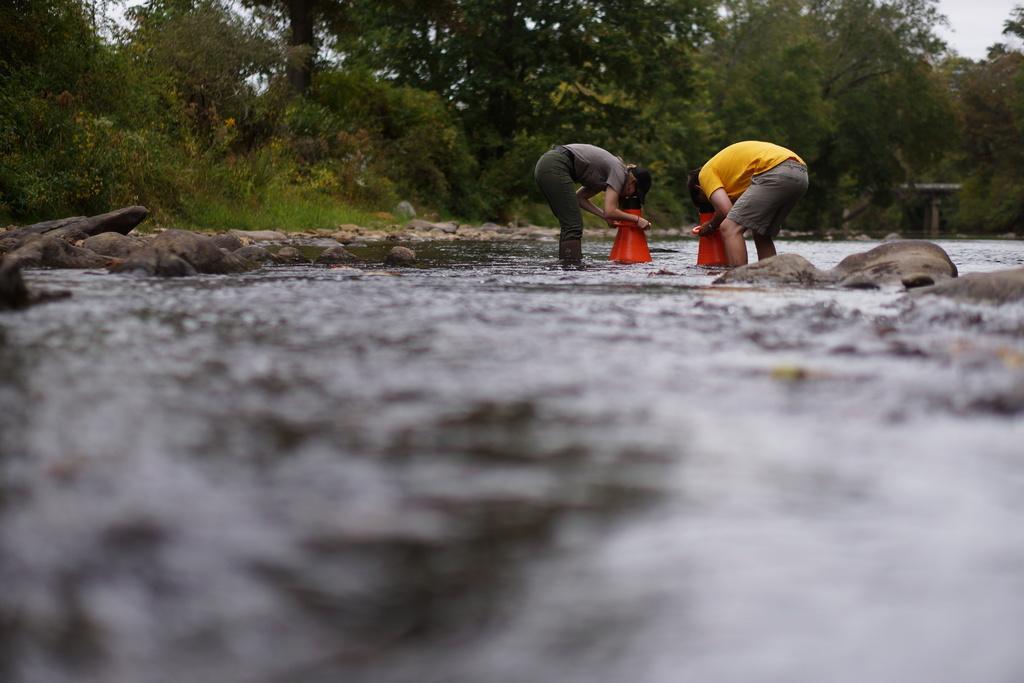In one or two sentences, can you explain what this image depicts? In this image we can see two men are standing. In front of them orange color thing is there. Bottom of the image water is present. Background of the image trees are there. Left side of the image stones are there. 